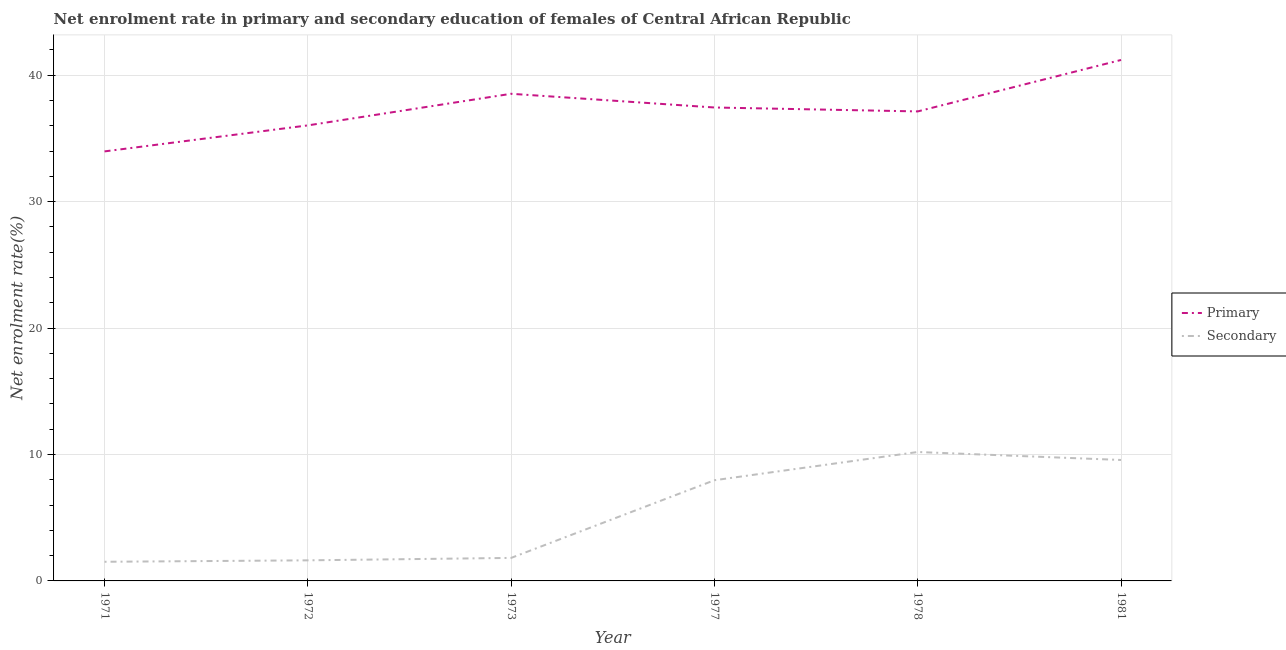Does the line corresponding to enrollment rate in primary education intersect with the line corresponding to enrollment rate in secondary education?
Keep it short and to the point. No. Is the number of lines equal to the number of legend labels?
Make the answer very short. Yes. What is the enrollment rate in primary education in 1972?
Provide a short and direct response. 36.03. Across all years, what is the maximum enrollment rate in secondary education?
Keep it short and to the point. 10.2. Across all years, what is the minimum enrollment rate in secondary education?
Ensure brevity in your answer.  1.51. In which year was the enrollment rate in secondary education maximum?
Offer a terse response. 1978. In which year was the enrollment rate in secondary education minimum?
Provide a succinct answer. 1971. What is the total enrollment rate in primary education in the graph?
Your answer should be very brief. 224.31. What is the difference between the enrollment rate in secondary education in 1971 and that in 1981?
Ensure brevity in your answer.  -8.05. What is the difference between the enrollment rate in primary education in 1972 and the enrollment rate in secondary education in 1971?
Your response must be concise. 34.51. What is the average enrollment rate in primary education per year?
Offer a terse response. 37.38. In the year 1971, what is the difference between the enrollment rate in primary education and enrollment rate in secondary education?
Your response must be concise. 32.46. What is the ratio of the enrollment rate in primary education in 1977 to that in 1978?
Ensure brevity in your answer.  1.01. Is the difference between the enrollment rate in primary education in 1977 and 1981 greater than the difference between the enrollment rate in secondary education in 1977 and 1981?
Your answer should be compact. No. What is the difference between the highest and the second highest enrollment rate in primary education?
Your response must be concise. 2.67. What is the difference between the highest and the lowest enrollment rate in secondary education?
Make the answer very short. 8.68. In how many years, is the enrollment rate in primary education greater than the average enrollment rate in primary education taken over all years?
Your response must be concise. 3. Is the sum of the enrollment rate in primary education in 1977 and 1981 greater than the maximum enrollment rate in secondary education across all years?
Offer a very short reply. Yes. Does the enrollment rate in primary education monotonically increase over the years?
Offer a very short reply. No. Is the enrollment rate in primary education strictly less than the enrollment rate in secondary education over the years?
Provide a short and direct response. No. How many lines are there?
Your response must be concise. 2. What is the difference between two consecutive major ticks on the Y-axis?
Your answer should be compact. 10. Are the values on the major ticks of Y-axis written in scientific E-notation?
Keep it short and to the point. No. Does the graph contain any zero values?
Offer a terse response. No. How many legend labels are there?
Your answer should be compact. 2. How are the legend labels stacked?
Keep it short and to the point. Vertical. What is the title of the graph?
Give a very brief answer. Net enrolment rate in primary and secondary education of females of Central African Republic. What is the label or title of the X-axis?
Offer a very short reply. Year. What is the label or title of the Y-axis?
Provide a succinct answer. Net enrolment rate(%). What is the Net enrolment rate(%) in Primary in 1971?
Your response must be concise. 33.97. What is the Net enrolment rate(%) of Secondary in 1971?
Make the answer very short. 1.51. What is the Net enrolment rate(%) of Primary in 1972?
Your answer should be compact. 36.03. What is the Net enrolment rate(%) of Secondary in 1972?
Offer a very short reply. 1.63. What is the Net enrolment rate(%) of Primary in 1973?
Provide a short and direct response. 38.53. What is the Net enrolment rate(%) in Secondary in 1973?
Make the answer very short. 1.82. What is the Net enrolment rate(%) in Primary in 1977?
Provide a short and direct response. 37.44. What is the Net enrolment rate(%) in Secondary in 1977?
Make the answer very short. 7.96. What is the Net enrolment rate(%) in Primary in 1978?
Keep it short and to the point. 37.13. What is the Net enrolment rate(%) of Secondary in 1978?
Your answer should be very brief. 10.2. What is the Net enrolment rate(%) of Primary in 1981?
Offer a very short reply. 41.2. What is the Net enrolment rate(%) in Secondary in 1981?
Offer a terse response. 9.57. Across all years, what is the maximum Net enrolment rate(%) of Primary?
Your response must be concise. 41.2. Across all years, what is the maximum Net enrolment rate(%) of Secondary?
Provide a succinct answer. 10.2. Across all years, what is the minimum Net enrolment rate(%) of Primary?
Make the answer very short. 33.97. Across all years, what is the minimum Net enrolment rate(%) of Secondary?
Offer a terse response. 1.51. What is the total Net enrolment rate(%) of Primary in the graph?
Your response must be concise. 224.31. What is the total Net enrolment rate(%) of Secondary in the graph?
Your answer should be very brief. 32.69. What is the difference between the Net enrolment rate(%) in Primary in 1971 and that in 1972?
Make the answer very short. -2.06. What is the difference between the Net enrolment rate(%) of Secondary in 1971 and that in 1972?
Offer a terse response. -0.11. What is the difference between the Net enrolment rate(%) of Primary in 1971 and that in 1973?
Your answer should be very brief. -4.56. What is the difference between the Net enrolment rate(%) in Secondary in 1971 and that in 1973?
Provide a succinct answer. -0.31. What is the difference between the Net enrolment rate(%) of Primary in 1971 and that in 1977?
Your answer should be compact. -3.47. What is the difference between the Net enrolment rate(%) of Secondary in 1971 and that in 1977?
Your answer should be very brief. -6.45. What is the difference between the Net enrolment rate(%) of Primary in 1971 and that in 1978?
Your answer should be very brief. -3.16. What is the difference between the Net enrolment rate(%) in Secondary in 1971 and that in 1978?
Offer a terse response. -8.68. What is the difference between the Net enrolment rate(%) of Primary in 1971 and that in 1981?
Provide a short and direct response. -7.23. What is the difference between the Net enrolment rate(%) in Secondary in 1971 and that in 1981?
Provide a succinct answer. -8.05. What is the difference between the Net enrolment rate(%) of Primary in 1972 and that in 1973?
Your answer should be very brief. -2.5. What is the difference between the Net enrolment rate(%) of Secondary in 1972 and that in 1973?
Provide a succinct answer. -0.19. What is the difference between the Net enrolment rate(%) of Primary in 1972 and that in 1977?
Ensure brevity in your answer.  -1.42. What is the difference between the Net enrolment rate(%) of Secondary in 1972 and that in 1977?
Offer a very short reply. -6.34. What is the difference between the Net enrolment rate(%) in Primary in 1972 and that in 1978?
Offer a very short reply. -1.1. What is the difference between the Net enrolment rate(%) in Secondary in 1972 and that in 1978?
Offer a very short reply. -8.57. What is the difference between the Net enrolment rate(%) in Primary in 1972 and that in 1981?
Keep it short and to the point. -5.17. What is the difference between the Net enrolment rate(%) of Secondary in 1972 and that in 1981?
Keep it short and to the point. -7.94. What is the difference between the Net enrolment rate(%) of Primary in 1973 and that in 1977?
Make the answer very short. 1.08. What is the difference between the Net enrolment rate(%) of Secondary in 1973 and that in 1977?
Make the answer very short. -6.14. What is the difference between the Net enrolment rate(%) of Primary in 1973 and that in 1978?
Your answer should be compact. 1.4. What is the difference between the Net enrolment rate(%) of Secondary in 1973 and that in 1978?
Ensure brevity in your answer.  -8.38. What is the difference between the Net enrolment rate(%) of Primary in 1973 and that in 1981?
Make the answer very short. -2.67. What is the difference between the Net enrolment rate(%) of Secondary in 1973 and that in 1981?
Make the answer very short. -7.75. What is the difference between the Net enrolment rate(%) of Primary in 1977 and that in 1978?
Make the answer very short. 0.31. What is the difference between the Net enrolment rate(%) of Secondary in 1977 and that in 1978?
Keep it short and to the point. -2.23. What is the difference between the Net enrolment rate(%) in Primary in 1977 and that in 1981?
Offer a terse response. -3.76. What is the difference between the Net enrolment rate(%) of Secondary in 1977 and that in 1981?
Make the answer very short. -1.6. What is the difference between the Net enrolment rate(%) in Primary in 1978 and that in 1981?
Offer a terse response. -4.07. What is the difference between the Net enrolment rate(%) in Secondary in 1978 and that in 1981?
Keep it short and to the point. 0.63. What is the difference between the Net enrolment rate(%) in Primary in 1971 and the Net enrolment rate(%) in Secondary in 1972?
Make the answer very short. 32.34. What is the difference between the Net enrolment rate(%) in Primary in 1971 and the Net enrolment rate(%) in Secondary in 1973?
Your response must be concise. 32.15. What is the difference between the Net enrolment rate(%) in Primary in 1971 and the Net enrolment rate(%) in Secondary in 1977?
Your answer should be very brief. 26.01. What is the difference between the Net enrolment rate(%) in Primary in 1971 and the Net enrolment rate(%) in Secondary in 1978?
Provide a succinct answer. 23.77. What is the difference between the Net enrolment rate(%) of Primary in 1971 and the Net enrolment rate(%) of Secondary in 1981?
Offer a terse response. 24.41. What is the difference between the Net enrolment rate(%) in Primary in 1972 and the Net enrolment rate(%) in Secondary in 1973?
Provide a short and direct response. 34.21. What is the difference between the Net enrolment rate(%) in Primary in 1972 and the Net enrolment rate(%) in Secondary in 1977?
Make the answer very short. 28.06. What is the difference between the Net enrolment rate(%) in Primary in 1972 and the Net enrolment rate(%) in Secondary in 1978?
Provide a short and direct response. 25.83. What is the difference between the Net enrolment rate(%) in Primary in 1972 and the Net enrolment rate(%) in Secondary in 1981?
Make the answer very short. 26.46. What is the difference between the Net enrolment rate(%) of Primary in 1973 and the Net enrolment rate(%) of Secondary in 1977?
Offer a very short reply. 30.56. What is the difference between the Net enrolment rate(%) of Primary in 1973 and the Net enrolment rate(%) of Secondary in 1978?
Make the answer very short. 28.33. What is the difference between the Net enrolment rate(%) of Primary in 1973 and the Net enrolment rate(%) of Secondary in 1981?
Provide a succinct answer. 28.96. What is the difference between the Net enrolment rate(%) of Primary in 1977 and the Net enrolment rate(%) of Secondary in 1978?
Offer a terse response. 27.25. What is the difference between the Net enrolment rate(%) of Primary in 1977 and the Net enrolment rate(%) of Secondary in 1981?
Offer a very short reply. 27.88. What is the difference between the Net enrolment rate(%) in Primary in 1978 and the Net enrolment rate(%) in Secondary in 1981?
Keep it short and to the point. 27.57. What is the average Net enrolment rate(%) in Primary per year?
Your answer should be very brief. 37.38. What is the average Net enrolment rate(%) in Secondary per year?
Your response must be concise. 5.45. In the year 1971, what is the difference between the Net enrolment rate(%) in Primary and Net enrolment rate(%) in Secondary?
Your answer should be compact. 32.46. In the year 1972, what is the difference between the Net enrolment rate(%) in Primary and Net enrolment rate(%) in Secondary?
Make the answer very short. 34.4. In the year 1973, what is the difference between the Net enrolment rate(%) of Primary and Net enrolment rate(%) of Secondary?
Your answer should be compact. 36.71. In the year 1977, what is the difference between the Net enrolment rate(%) in Primary and Net enrolment rate(%) in Secondary?
Your answer should be compact. 29.48. In the year 1978, what is the difference between the Net enrolment rate(%) in Primary and Net enrolment rate(%) in Secondary?
Your response must be concise. 26.94. In the year 1981, what is the difference between the Net enrolment rate(%) in Primary and Net enrolment rate(%) in Secondary?
Your answer should be compact. 31.64. What is the ratio of the Net enrolment rate(%) in Primary in 1971 to that in 1972?
Provide a succinct answer. 0.94. What is the ratio of the Net enrolment rate(%) in Secondary in 1971 to that in 1972?
Keep it short and to the point. 0.93. What is the ratio of the Net enrolment rate(%) in Primary in 1971 to that in 1973?
Your response must be concise. 0.88. What is the ratio of the Net enrolment rate(%) in Secondary in 1971 to that in 1973?
Give a very brief answer. 0.83. What is the ratio of the Net enrolment rate(%) of Primary in 1971 to that in 1977?
Make the answer very short. 0.91. What is the ratio of the Net enrolment rate(%) in Secondary in 1971 to that in 1977?
Your answer should be compact. 0.19. What is the ratio of the Net enrolment rate(%) in Primary in 1971 to that in 1978?
Offer a very short reply. 0.91. What is the ratio of the Net enrolment rate(%) of Secondary in 1971 to that in 1978?
Provide a short and direct response. 0.15. What is the ratio of the Net enrolment rate(%) of Primary in 1971 to that in 1981?
Give a very brief answer. 0.82. What is the ratio of the Net enrolment rate(%) in Secondary in 1971 to that in 1981?
Provide a succinct answer. 0.16. What is the ratio of the Net enrolment rate(%) in Primary in 1972 to that in 1973?
Your response must be concise. 0.94. What is the ratio of the Net enrolment rate(%) of Secondary in 1972 to that in 1973?
Ensure brevity in your answer.  0.89. What is the ratio of the Net enrolment rate(%) in Primary in 1972 to that in 1977?
Give a very brief answer. 0.96. What is the ratio of the Net enrolment rate(%) of Secondary in 1972 to that in 1977?
Provide a short and direct response. 0.2. What is the ratio of the Net enrolment rate(%) of Primary in 1972 to that in 1978?
Offer a terse response. 0.97. What is the ratio of the Net enrolment rate(%) of Secondary in 1972 to that in 1978?
Ensure brevity in your answer.  0.16. What is the ratio of the Net enrolment rate(%) of Primary in 1972 to that in 1981?
Provide a short and direct response. 0.87. What is the ratio of the Net enrolment rate(%) in Secondary in 1972 to that in 1981?
Offer a terse response. 0.17. What is the ratio of the Net enrolment rate(%) in Primary in 1973 to that in 1977?
Provide a succinct answer. 1.03. What is the ratio of the Net enrolment rate(%) in Secondary in 1973 to that in 1977?
Ensure brevity in your answer.  0.23. What is the ratio of the Net enrolment rate(%) of Primary in 1973 to that in 1978?
Give a very brief answer. 1.04. What is the ratio of the Net enrolment rate(%) of Secondary in 1973 to that in 1978?
Ensure brevity in your answer.  0.18. What is the ratio of the Net enrolment rate(%) in Primary in 1973 to that in 1981?
Your answer should be compact. 0.94. What is the ratio of the Net enrolment rate(%) in Secondary in 1973 to that in 1981?
Provide a short and direct response. 0.19. What is the ratio of the Net enrolment rate(%) in Primary in 1977 to that in 1978?
Give a very brief answer. 1.01. What is the ratio of the Net enrolment rate(%) of Secondary in 1977 to that in 1978?
Offer a terse response. 0.78. What is the ratio of the Net enrolment rate(%) in Primary in 1977 to that in 1981?
Offer a very short reply. 0.91. What is the ratio of the Net enrolment rate(%) of Secondary in 1977 to that in 1981?
Offer a terse response. 0.83. What is the ratio of the Net enrolment rate(%) in Primary in 1978 to that in 1981?
Make the answer very short. 0.9. What is the ratio of the Net enrolment rate(%) of Secondary in 1978 to that in 1981?
Make the answer very short. 1.07. What is the difference between the highest and the second highest Net enrolment rate(%) in Primary?
Offer a very short reply. 2.67. What is the difference between the highest and the second highest Net enrolment rate(%) in Secondary?
Your answer should be very brief. 0.63. What is the difference between the highest and the lowest Net enrolment rate(%) in Primary?
Provide a short and direct response. 7.23. What is the difference between the highest and the lowest Net enrolment rate(%) in Secondary?
Offer a very short reply. 8.68. 